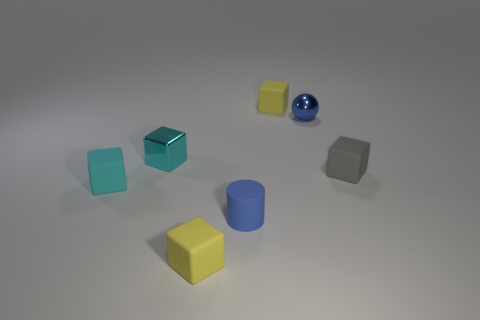Subtract all gray matte blocks. How many blocks are left? 4 Subtract all green cubes. Subtract all blue spheres. How many cubes are left? 5 Add 3 cyan objects. How many objects exist? 10 Subtract all blocks. How many objects are left? 2 Subtract 0 brown cubes. How many objects are left? 7 Subtract all cyan metal objects. Subtract all small yellow blocks. How many objects are left? 4 Add 1 small gray cubes. How many small gray cubes are left? 2 Add 6 matte cubes. How many matte cubes exist? 10 